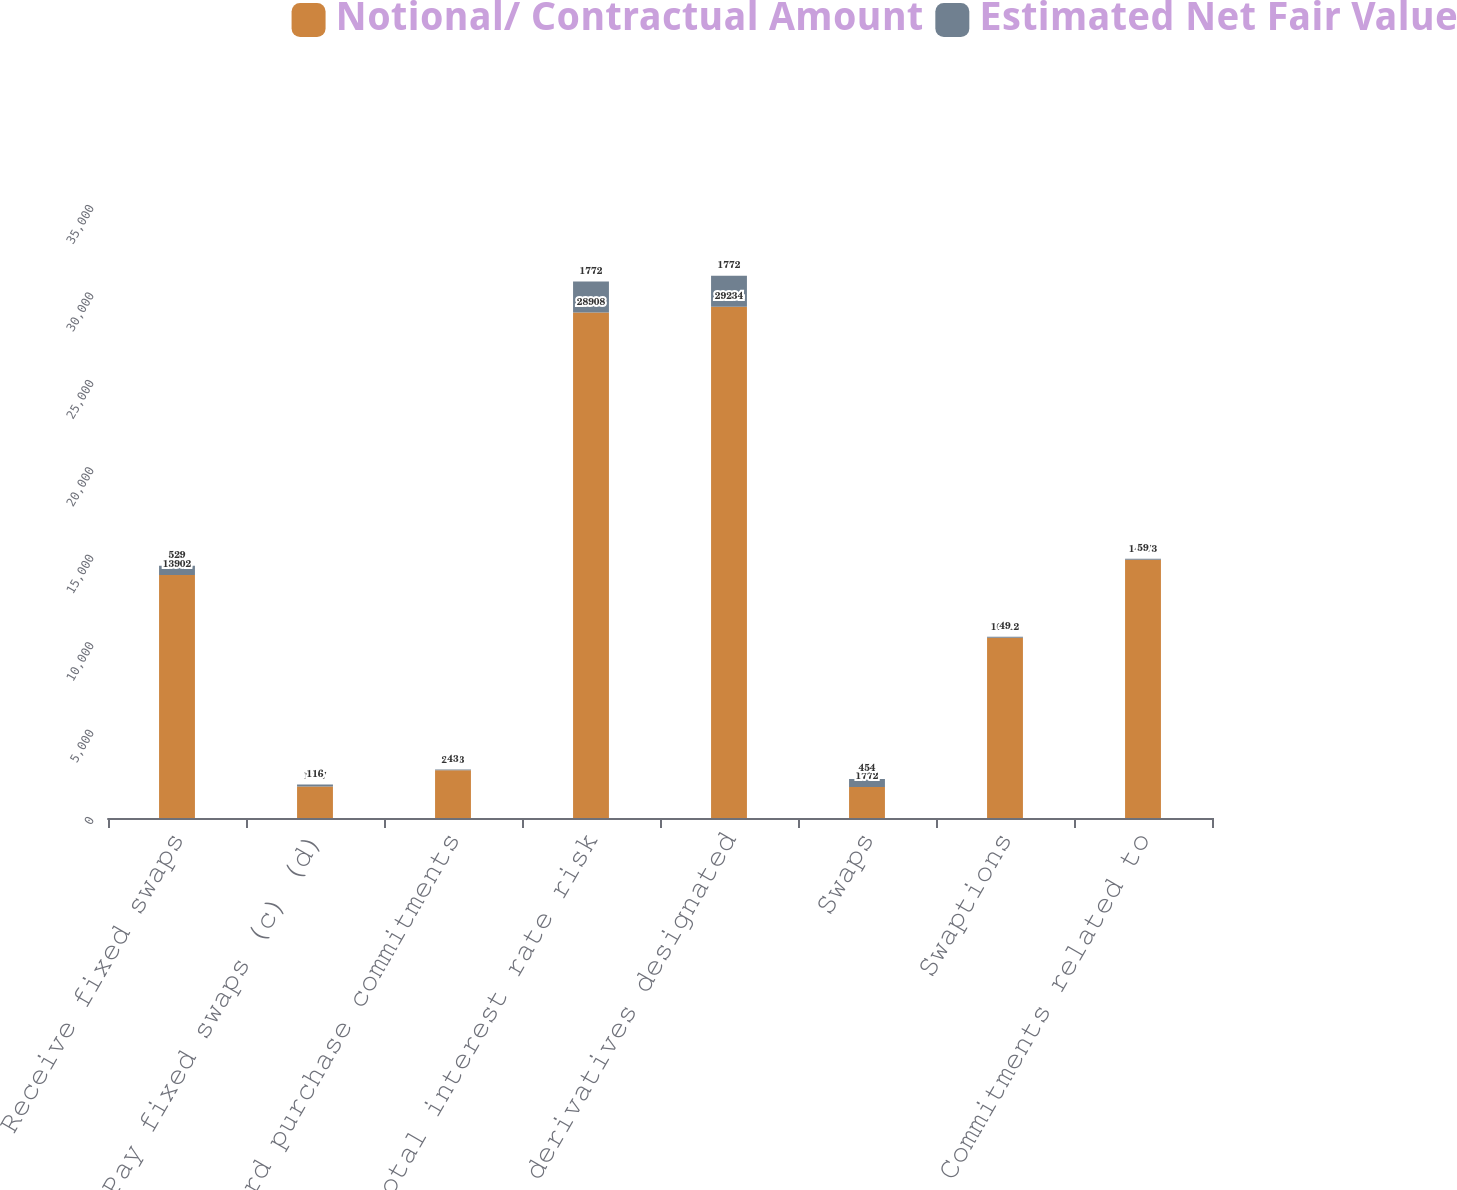Convert chart. <chart><loc_0><loc_0><loc_500><loc_500><stacked_bar_chart><ecel><fcel>Receive fixed swaps<fcel>Pay fixed swaps (c) (d)<fcel>Forward purchase commitments<fcel>Total interest rate risk<fcel>Total derivatives designated<fcel>Swaps<fcel>Swaptions<fcel>Commitments related to<nl><fcel>Notional/ Contractual Amount<fcel>13902<fcel>1797<fcel>2733<fcel>28908<fcel>29234<fcel>1772<fcel>10312<fcel>14773<nl><fcel>Estimated Net Fair Value<fcel>529<fcel>116<fcel>43<fcel>1772<fcel>1772<fcel>454<fcel>49<fcel>59<nl></chart> 